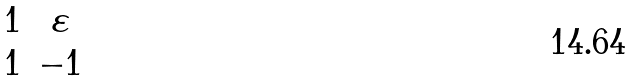<formula> <loc_0><loc_0><loc_500><loc_500>\begin{matrix} 1 & \varepsilon \\ 1 & - 1 \end{matrix}</formula> 